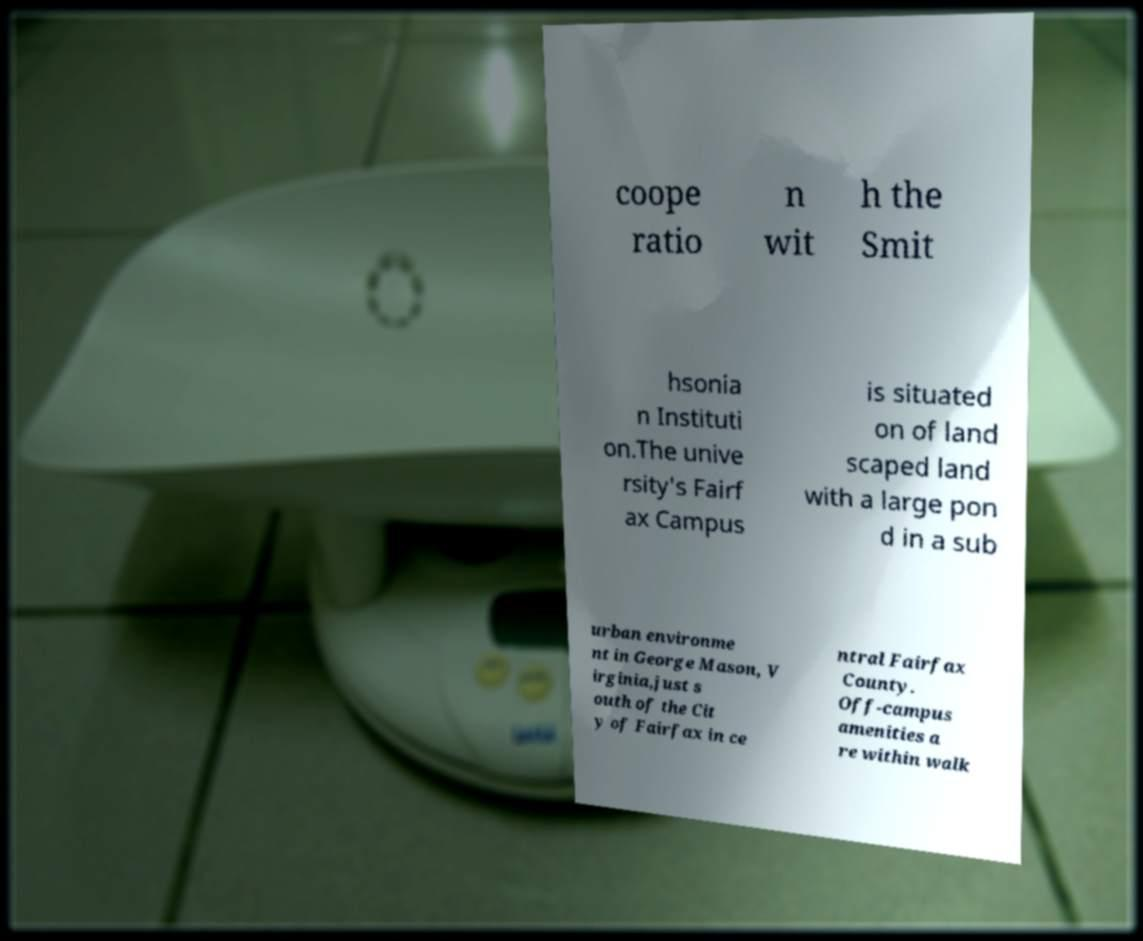What messages or text are displayed in this image? I need them in a readable, typed format. coope ratio n wit h the Smit hsonia n Instituti on.The unive rsity's Fairf ax Campus is situated on of land scaped land with a large pon d in a sub urban environme nt in George Mason, V irginia,just s outh of the Cit y of Fairfax in ce ntral Fairfax County. Off-campus amenities a re within walk 